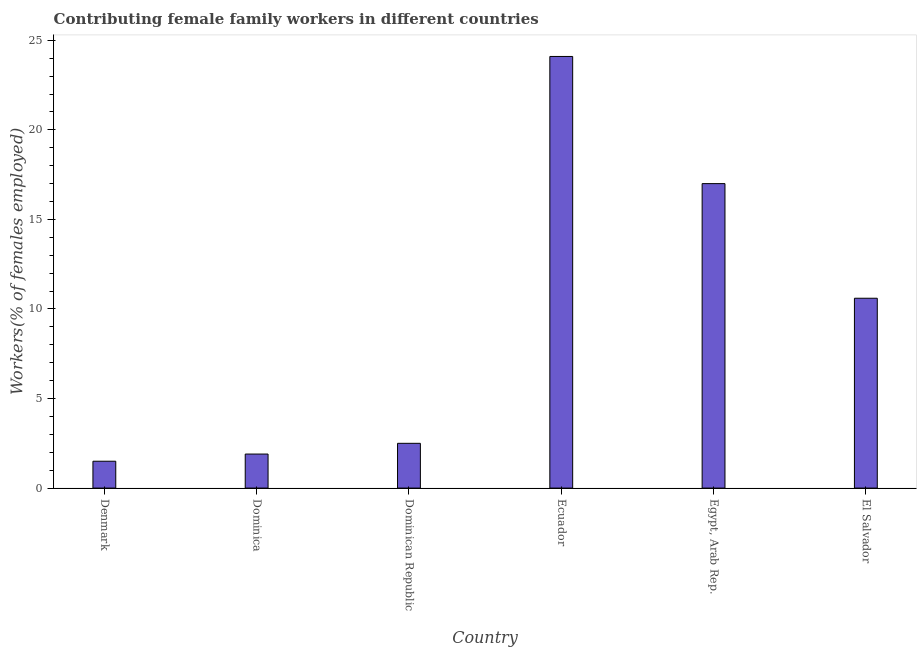Does the graph contain any zero values?
Give a very brief answer. No. Does the graph contain grids?
Your response must be concise. No. What is the title of the graph?
Keep it short and to the point. Contributing female family workers in different countries. What is the label or title of the X-axis?
Ensure brevity in your answer.  Country. What is the label or title of the Y-axis?
Keep it short and to the point. Workers(% of females employed). What is the contributing female family workers in Ecuador?
Provide a succinct answer. 24.1. Across all countries, what is the maximum contributing female family workers?
Provide a succinct answer. 24.1. Across all countries, what is the minimum contributing female family workers?
Your answer should be compact. 1.5. In which country was the contributing female family workers maximum?
Offer a terse response. Ecuador. In which country was the contributing female family workers minimum?
Provide a short and direct response. Denmark. What is the sum of the contributing female family workers?
Keep it short and to the point. 57.6. What is the difference between the contributing female family workers in Denmark and Egypt, Arab Rep.?
Your response must be concise. -15.5. What is the median contributing female family workers?
Offer a terse response. 6.55. In how many countries, is the contributing female family workers greater than 17 %?
Ensure brevity in your answer.  1. What is the ratio of the contributing female family workers in Dominica to that in Ecuador?
Your answer should be very brief. 0.08. Is the difference between the contributing female family workers in Dominica and Egypt, Arab Rep. greater than the difference between any two countries?
Your response must be concise. No. What is the difference between the highest and the lowest contributing female family workers?
Your answer should be compact. 22.6. What is the difference between two consecutive major ticks on the Y-axis?
Offer a very short reply. 5. Are the values on the major ticks of Y-axis written in scientific E-notation?
Provide a short and direct response. No. What is the Workers(% of females employed) in Dominica?
Provide a succinct answer. 1.9. What is the Workers(% of females employed) in Ecuador?
Offer a very short reply. 24.1. What is the Workers(% of females employed) in El Salvador?
Provide a short and direct response. 10.6. What is the difference between the Workers(% of females employed) in Denmark and Dominica?
Keep it short and to the point. -0.4. What is the difference between the Workers(% of females employed) in Denmark and Ecuador?
Make the answer very short. -22.6. What is the difference between the Workers(% of females employed) in Denmark and Egypt, Arab Rep.?
Offer a terse response. -15.5. What is the difference between the Workers(% of females employed) in Dominica and Dominican Republic?
Keep it short and to the point. -0.6. What is the difference between the Workers(% of females employed) in Dominica and Ecuador?
Offer a terse response. -22.2. What is the difference between the Workers(% of females employed) in Dominica and Egypt, Arab Rep.?
Provide a short and direct response. -15.1. What is the difference between the Workers(% of females employed) in Dominica and El Salvador?
Provide a short and direct response. -8.7. What is the difference between the Workers(% of females employed) in Dominican Republic and Ecuador?
Make the answer very short. -21.6. What is the difference between the Workers(% of females employed) in Ecuador and Egypt, Arab Rep.?
Give a very brief answer. 7.1. What is the difference between the Workers(% of females employed) in Ecuador and El Salvador?
Ensure brevity in your answer.  13.5. What is the ratio of the Workers(% of females employed) in Denmark to that in Dominica?
Offer a terse response. 0.79. What is the ratio of the Workers(% of females employed) in Denmark to that in Ecuador?
Provide a short and direct response. 0.06. What is the ratio of the Workers(% of females employed) in Denmark to that in Egypt, Arab Rep.?
Give a very brief answer. 0.09. What is the ratio of the Workers(% of females employed) in Denmark to that in El Salvador?
Your response must be concise. 0.14. What is the ratio of the Workers(% of females employed) in Dominica to that in Dominican Republic?
Provide a short and direct response. 0.76. What is the ratio of the Workers(% of females employed) in Dominica to that in Ecuador?
Ensure brevity in your answer.  0.08. What is the ratio of the Workers(% of females employed) in Dominica to that in Egypt, Arab Rep.?
Give a very brief answer. 0.11. What is the ratio of the Workers(% of females employed) in Dominica to that in El Salvador?
Your response must be concise. 0.18. What is the ratio of the Workers(% of females employed) in Dominican Republic to that in Ecuador?
Your answer should be compact. 0.1. What is the ratio of the Workers(% of females employed) in Dominican Republic to that in Egypt, Arab Rep.?
Keep it short and to the point. 0.15. What is the ratio of the Workers(% of females employed) in Dominican Republic to that in El Salvador?
Offer a very short reply. 0.24. What is the ratio of the Workers(% of females employed) in Ecuador to that in Egypt, Arab Rep.?
Give a very brief answer. 1.42. What is the ratio of the Workers(% of females employed) in Ecuador to that in El Salvador?
Offer a very short reply. 2.27. What is the ratio of the Workers(% of females employed) in Egypt, Arab Rep. to that in El Salvador?
Give a very brief answer. 1.6. 